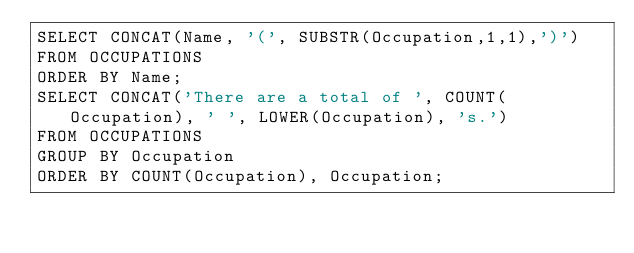<code> <loc_0><loc_0><loc_500><loc_500><_SQL_>SELECT CONCAT(Name, '(', SUBSTR(Occupation,1,1),')')
FROM OCCUPATIONS 
ORDER BY Name;
SELECT CONCAT('There are a total of ', COUNT(Occupation), ' ', LOWER(Occupation), 's.')
FROM OCCUPATIONS
GROUP BY Occupation 
ORDER BY COUNT(Occupation), Occupation;</code> 